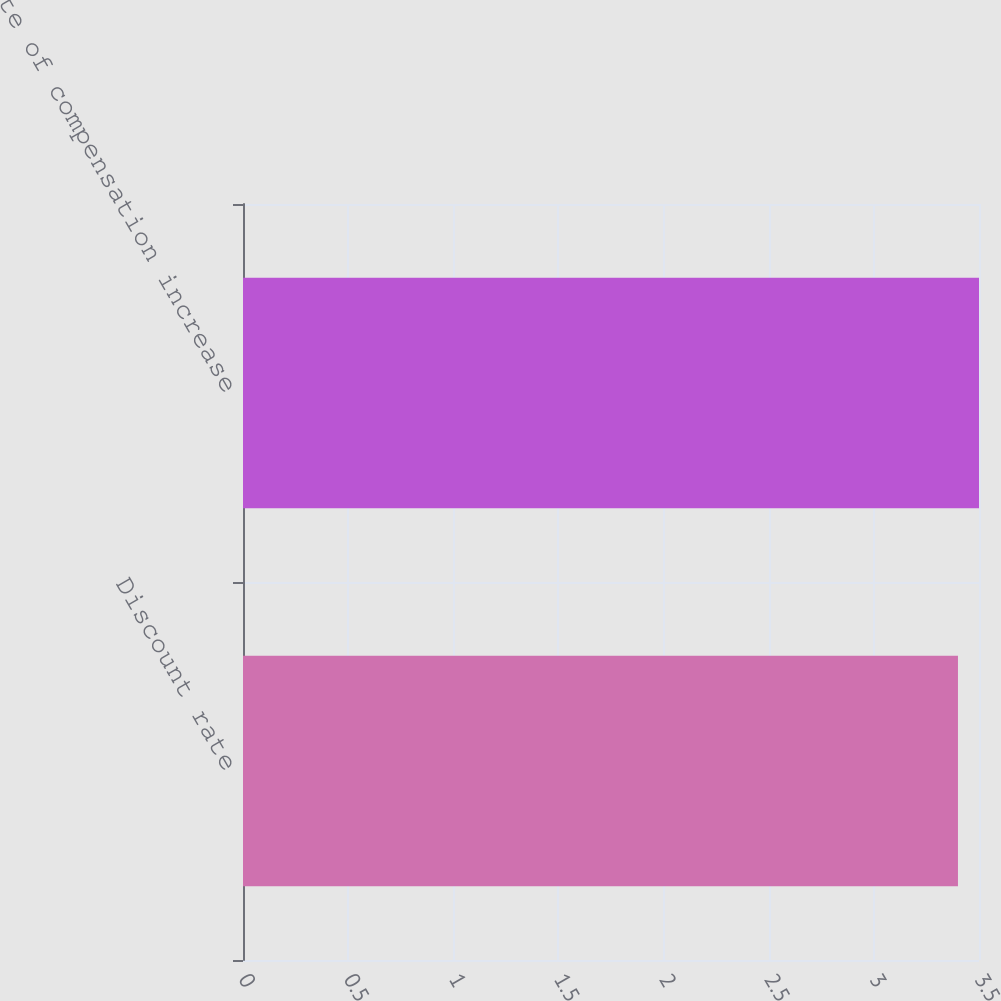Convert chart. <chart><loc_0><loc_0><loc_500><loc_500><bar_chart><fcel>Discount rate<fcel>Rate of compensation increase<nl><fcel>3.4<fcel>3.5<nl></chart> 